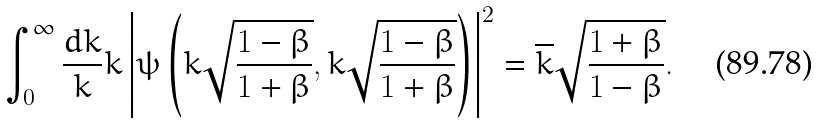<formula> <loc_0><loc_0><loc_500><loc_500>\int _ { 0 } ^ { \infty } \frac { d k } { k } k \left | \psi \left ( k \sqrt { \frac { 1 - \beta } { 1 + \beta } } , k \sqrt { \frac { 1 - \beta } { 1 + \beta } } \right ) \right | ^ { 2 } = \overline { k } \sqrt { \frac { 1 + \beta } { 1 - \beta } } .</formula> 